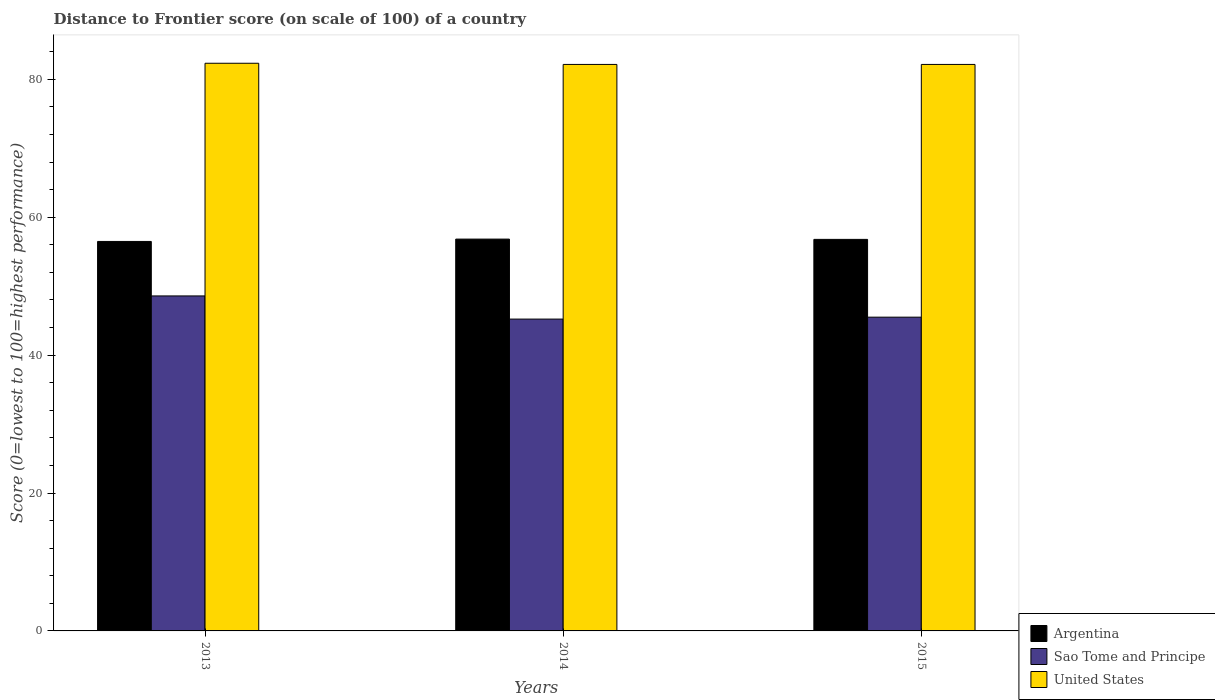How many different coloured bars are there?
Provide a succinct answer. 3. How many bars are there on the 3rd tick from the right?
Your answer should be compact. 3. What is the label of the 2nd group of bars from the left?
Offer a very short reply. 2014. What is the distance to frontier score of in Sao Tome and Principe in 2015?
Make the answer very short. 45.5. Across all years, what is the maximum distance to frontier score of in United States?
Ensure brevity in your answer.  82.32. Across all years, what is the minimum distance to frontier score of in Argentina?
Give a very brief answer. 56.48. In which year was the distance to frontier score of in United States minimum?
Give a very brief answer. 2014. What is the total distance to frontier score of in Sao Tome and Principe in the graph?
Your response must be concise. 139.3. What is the difference between the distance to frontier score of in United States in 2013 and that in 2014?
Provide a succinct answer. 0.17. What is the difference between the distance to frontier score of in Sao Tome and Principe in 2015 and the distance to frontier score of in United States in 2014?
Your answer should be very brief. -36.65. What is the average distance to frontier score of in Sao Tome and Principe per year?
Keep it short and to the point. 46.43. In the year 2013, what is the difference between the distance to frontier score of in Argentina and distance to frontier score of in Sao Tome and Principe?
Provide a succinct answer. 7.9. What is the ratio of the distance to frontier score of in United States in 2013 to that in 2015?
Your answer should be compact. 1. What is the difference between the highest and the second highest distance to frontier score of in United States?
Your response must be concise. 0.17. What is the difference between the highest and the lowest distance to frontier score of in Sao Tome and Principe?
Your answer should be very brief. 3.36. What does the 1st bar from the left in 2014 represents?
Keep it short and to the point. Argentina. What does the 1st bar from the right in 2013 represents?
Your answer should be compact. United States. Are all the bars in the graph horizontal?
Your answer should be compact. No. How many years are there in the graph?
Your answer should be very brief. 3. What is the difference between two consecutive major ticks on the Y-axis?
Your response must be concise. 20. Are the values on the major ticks of Y-axis written in scientific E-notation?
Your answer should be compact. No. Does the graph contain grids?
Your response must be concise. No. How many legend labels are there?
Offer a terse response. 3. How are the legend labels stacked?
Your answer should be very brief. Vertical. What is the title of the graph?
Your answer should be compact. Distance to Frontier score (on scale of 100) of a country. What is the label or title of the X-axis?
Make the answer very short. Years. What is the label or title of the Y-axis?
Ensure brevity in your answer.  Score (0=lowest to 100=highest performance). What is the Score (0=lowest to 100=highest performance) in Argentina in 2013?
Keep it short and to the point. 56.48. What is the Score (0=lowest to 100=highest performance) of Sao Tome and Principe in 2013?
Offer a very short reply. 48.58. What is the Score (0=lowest to 100=highest performance) of United States in 2013?
Your answer should be very brief. 82.32. What is the Score (0=lowest to 100=highest performance) of Argentina in 2014?
Offer a very short reply. 56.82. What is the Score (0=lowest to 100=highest performance) of Sao Tome and Principe in 2014?
Offer a terse response. 45.22. What is the Score (0=lowest to 100=highest performance) of United States in 2014?
Your response must be concise. 82.15. What is the Score (0=lowest to 100=highest performance) of Argentina in 2015?
Keep it short and to the point. 56.78. What is the Score (0=lowest to 100=highest performance) of Sao Tome and Principe in 2015?
Provide a succinct answer. 45.5. What is the Score (0=lowest to 100=highest performance) in United States in 2015?
Ensure brevity in your answer.  82.15. Across all years, what is the maximum Score (0=lowest to 100=highest performance) of Argentina?
Make the answer very short. 56.82. Across all years, what is the maximum Score (0=lowest to 100=highest performance) in Sao Tome and Principe?
Offer a very short reply. 48.58. Across all years, what is the maximum Score (0=lowest to 100=highest performance) of United States?
Your answer should be compact. 82.32. Across all years, what is the minimum Score (0=lowest to 100=highest performance) in Argentina?
Give a very brief answer. 56.48. Across all years, what is the minimum Score (0=lowest to 100=highest performance) in Sao Tome and Principe?
Your answer should be very brief. 45.22. Across all years, what is the minimum Score (0=lowest to 100=highest performance) of United States?
Offer a very short reply. 82.15. What is the total Score (0=lowest to 100=highest performance) of Argentina in the graph?
Provide a succinct answer. 170.08. What is the total Score (0=lowest to 100=highest performance) in Sao Tome and Principe in the graph?
Offer a terse response. 139.3. What is the total Score (0=lowest to 100=highest performance) of United States in the graph?
Ensure brevity in your answer.  246.62. What is the difference between the Score (0=lowest to 100=highest performance) in Argentina in 2013 and that in 2014?
Ensure brevity in your answer.  -0.34. What is the difference between the Score (0=lowest to 100=highest performance) of Sao Tome and Principe in 2013 and that in 2014?
Give a very brief answer. 3.36. What is the difference between the Score (0=lowest to 100=highest performance) in United States in 2013 and that in 2014?
Give a very brief answer. 0.17. What is the difference between the Score (0=lowest to 100=highest performance) in Sao Tome and Principe in 2013 and that in 2015?
Keep it short and to the point. 3.08. What is the difference between the Score (0=lowest to 100=highest performance) of United States in 2013 and that in 2015?
Your answer should be very brief. 0.17. What is the difference between the Score (0=lowest to 100=highest performance) of Argentina in 2014 and that in 2015?
Provide a succinct answer. 0.04. What is the difference between the Score (0=lowest to 100=highest performance) of Sao Tome and Principe in 2014 and that in 2015?
Offer a terse response. -0.28. What is the difference between the Score (0=lowest to 100=highest performance) of United States in 2014 and that in 2015?
Offer a very short reply. 0. What is the difference between the Score (0=lowest to 100=highest performance) of Argentina in 2013 and the Score (0=lowest to 100=highest performance) of Sao Tome and Principe in 2014?
Give a very brief answer. 11.26. What is the difference between the Score (0=lowest to 100=highest performance) in Argentina in 2013 and the Score (0=lowest to 100=highest performance) in United States in 2014?
Offer a very short reply. -25.67. What is the difference between the Score (0=lowest to 100=highest performance) in Sao Tome and Principe in 2013 and the Score (0=lowest to 100=highest performance) in United States in 2014?
Your response must be concise. -33.57. What is the difference between the Score (0=lowest to 100=highest performance) in Argentina in 2013 and the Score (0=lowest to 100=highest performance) in Sao Tome and Principe in 2015?
Make the answer very short. 10.98. What is the difference between the Score (0=lowest to 100=highest performance) of Argentina in 2013 and the Score (0=lowest to 100=highest performance) of United States in 2015?
Ensure brevity in your answer.  -25.67. What is the difference between the Score (0=lowest to 100=highest performance) in Sao Tome and Principe in 2013 and the Score (0=lowest to 100=highest performance) in United States in 2015?
Give a very brief answer. -33.57. What is the difference between the Score (0=lowest to 100=highest performance) of Argentina in 2014 and the Score (0=lowest to 100=highest performance) of Sao Tome and Principe in 2015?
Keep it short and to the point. 11.32. What is the difference between the Score (0=lowest to 100=highest performance) of Argentina in 2014 and the Score (0=lowest to 100=highest performance) of United States in 2015?
Offer a terse response. -25.33. What is the difference between the Score (0=lowest to 100=highest performance) in Sao Tome and Principe in 2014 and the Score (0=lowest to 100=highest performance) in United States in 2015?
Your answer should be compact. -36.93. What is the average Score (0=lowest to 100=highest performance) in Argentina per year?
Keep it short and to the point. 56.69. What is the average Score (0=lowest to 100=highest performance) of Sao Tome and Principe per year?
Ensure brevity in your answer.  46.43. What is the average Score (0=lowest to 100=highest performance) of United States per year?
Provide a succinct answer. 82.21. In the year 2013, what is the difference between the Score (0=lowest to 100=highest performance) of Argentina and Score (0=lowest to 100=highest performance) of Sao Tome and Principe?
Ensure brevity in your answer.  7.9. In the year 2013, what is the difference between the Score (0=lowest to 100=highest performance) in Argentina and Score (0=lowest to 100=highest performance) in United States?
Provide a succinct answer. -25.84. In the year 2013, what is the difference between the Score (0=lowest to 100=highest performance) in Sao Tome and Principe and Score (0=lowest to 100=highest performance) in United States?
Offer a very short reply. -33.74. In the year 2014, what is the difference between the Score (0=lowest to 100=highest performance) in Argentina and Score (0=lowest to 100=highest performance) in Sao Tome and Principe?
Give a very brief answer. 11.6. In the year 2014, what is the difference between the Score (0=lowest to 100=highest performance) in Argentina and Score (0=lowest to 100=highest performance) in United States?
Give a very brief answer. -25.33. In the year 2014, what is the difference between the Score (0=lowest to 100=highest performance) of Sao Tome and Principe and Score (0=lowest to 100=highest performance) of United States?
Provide a succinct answer. -36.93. In the year 2015, what is the difference between the Score (0=lowest to 100=highest performance) in Argentina and Score (0=lowest to 100=highest performance) in Sao Tome and Principe?
Your response must be concise. 11.28. In the year 2015, what is the difference between the Score (0=lowest to 100=highest performance) in Argentina and Score (0=lowest to 100=highest performance) in United States?
Provide a succinct answer. -25.37. In the year 2015, what is the difference between the Score (0=lowest to 100=highest performance) in Sao Tome and Principe and Score (0=lowest to 100=highest performance) in United States?
Keep it short and to the point. -36.65. What is the ratio of the Score (0=lowest to 100=highest performance) in Sao Tome and Principe in 2013 to that in 2014?
Make the answer very short. 1.07. What is the ratio of the Score (0=lowest to 100=highest performance) in Sao Tome and Principe in 2013 to that in 2015?
Provide a short and direct response. 1.07. What is the ratio of the Score (0=lowest to 100=highest performance) of Argentina in 2014 to that in 2015?
Offer a very short reply. 1. What is the ratio of the Score (0=lowest to 100=highest performance) of United States in 2014 to that in 2015?
Ensure brevity in your answer.  1. What is the difference between the highest and the second highest Score (0=lowest to 100=highest performance) in Sao Tome and Principe?
Your response must be concise. 3.08. What is the difference between the highest and the second highest Score (0=lowest to 100=highest performance) of United States?
Offer a very short reply. 0.17. What is the difference between the highest and the lowest Score (0=lowest to 100=highest performance) in Argentina?
Offer a terse response. 0.34. What is the difference between the highest and the lowest Score (0=lowest to 100=highest performance) of Sao Tome and Principe?
Provide a short and direct response. 3.36. What is the difference between the highest and the lowest Score (0=lowest to 100=highest performance) of United States?
Offer a very short reply. 0.17. 